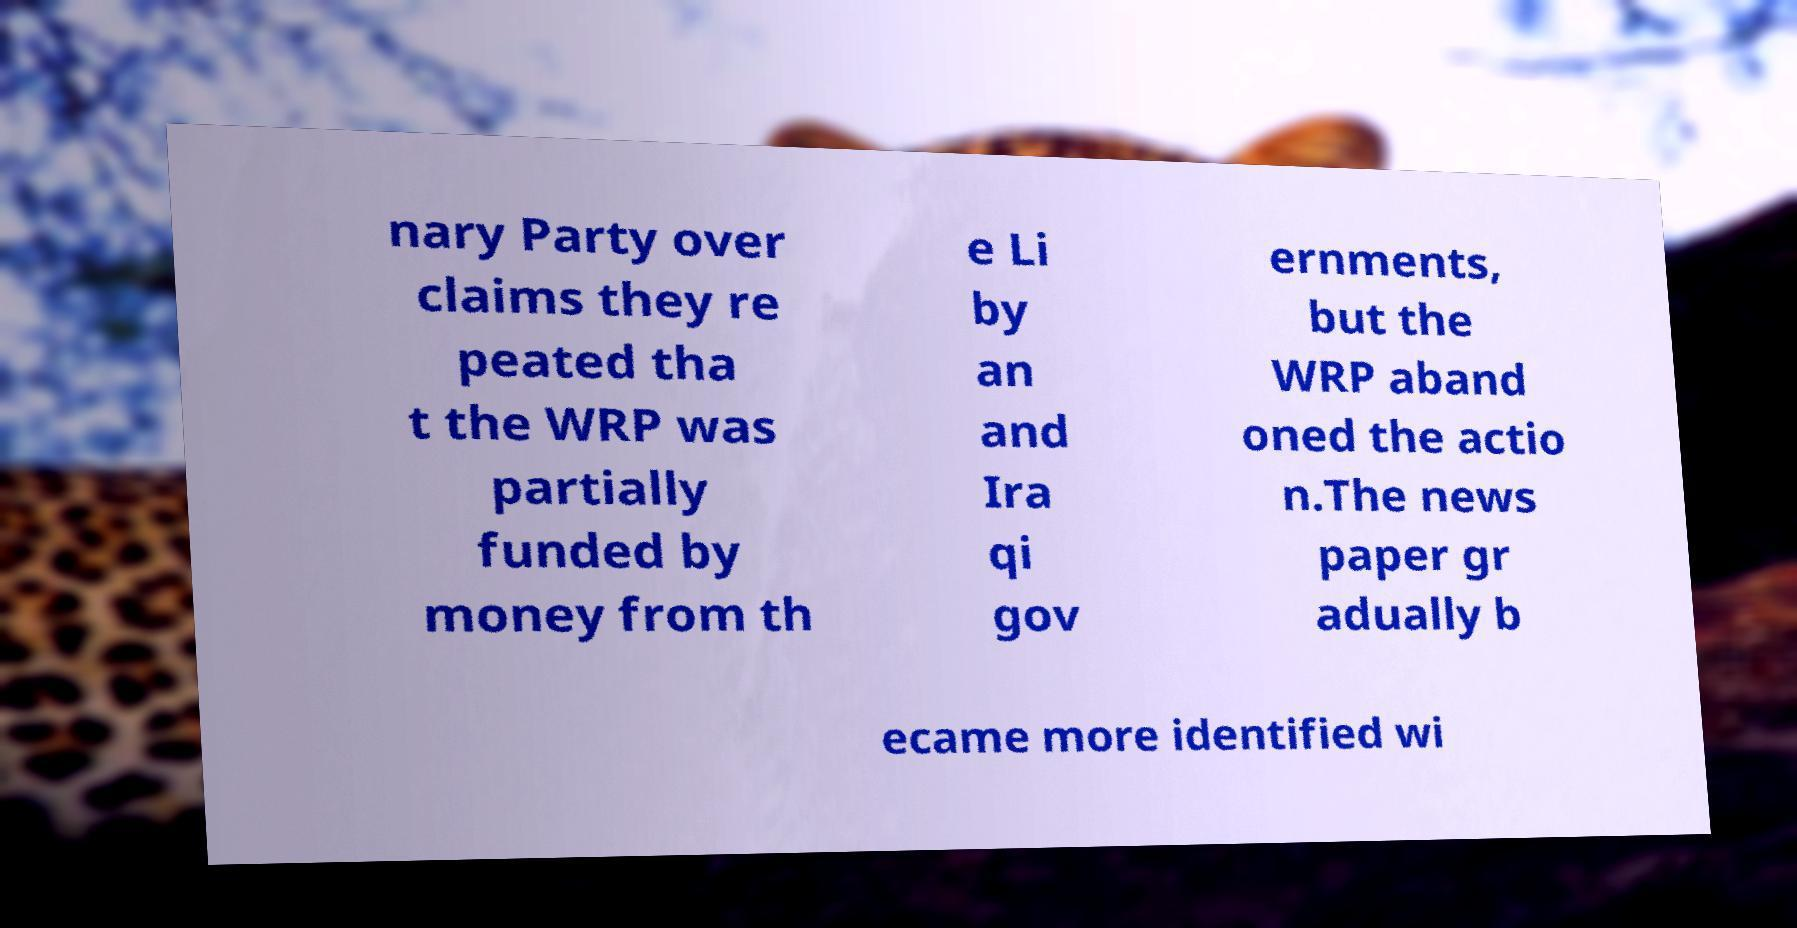Please identify and transcribe the text found in this image. nary Party over claims they re peated tha t the WRP was partially funded by money from th e Li by an and Ira qi gov ernments, but the WRP aband oned the actio n.The news paper gr adually b ecame more identified wi 